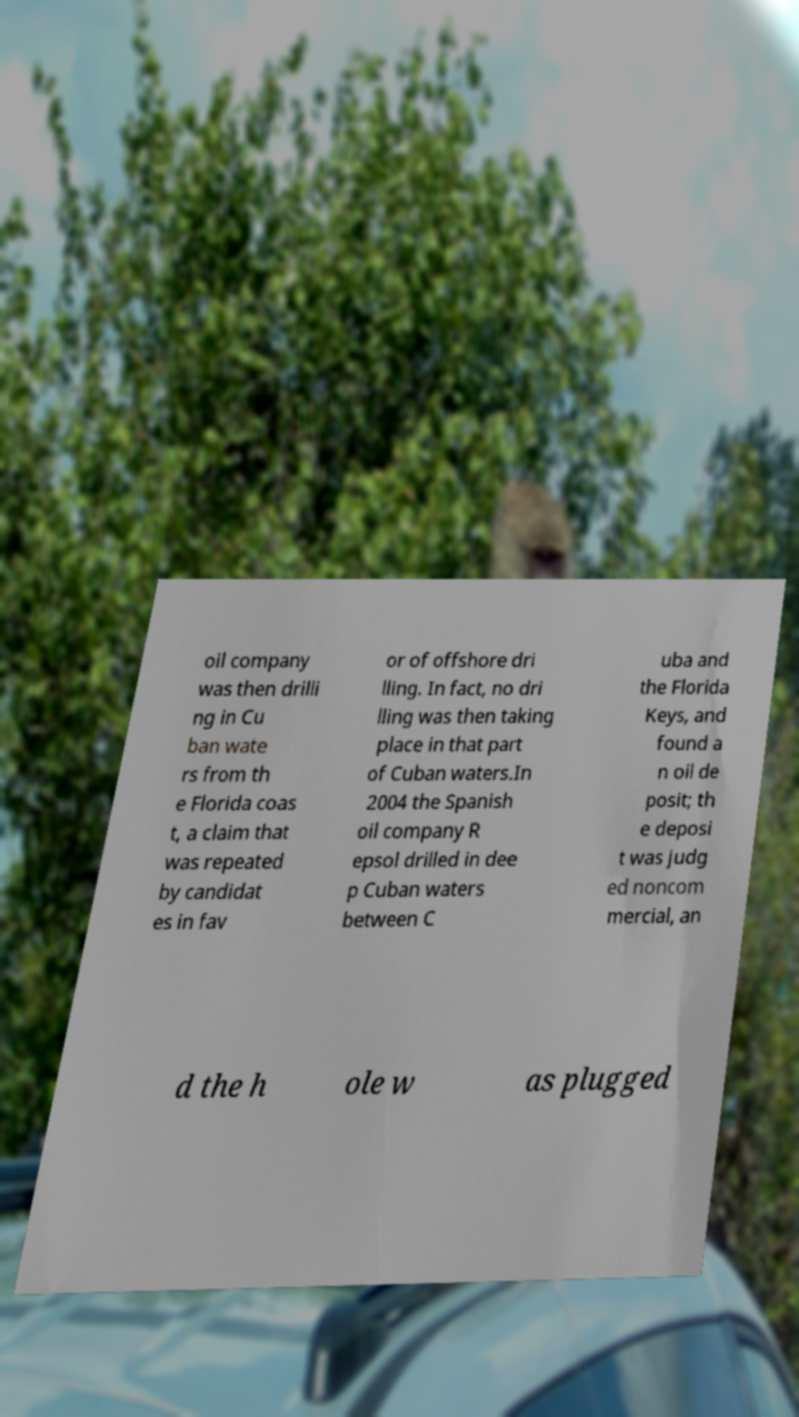For documentation purposes, I need the text within this image transcribed. Could you provide that? oil company was then drilli ng in Cu ban wate rs from th e Florida coas t, a claim that was repeated by candidat es in fav or of offshore dri lling. In fact, no dri lling was then taking place in that part of Cuban waters.In 2004 the Spanish oil company R epsol drilled in dee p Cuban waters between C uba and the Florida Keys, and found a n oil de posit; th e deposi t was judg ed noncom mercial, an d the h ole w as plugged 